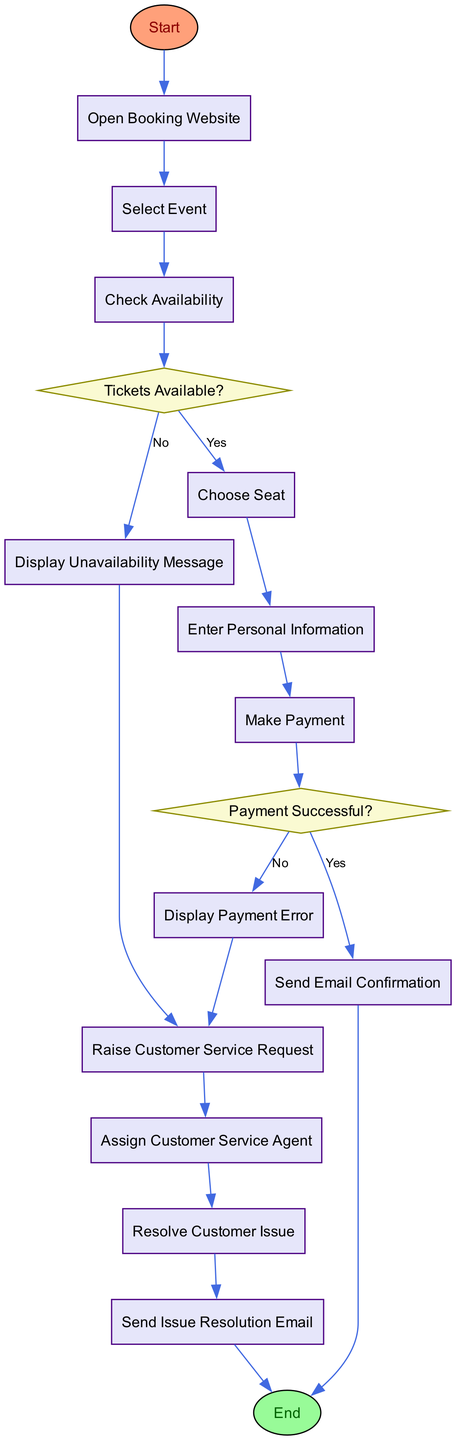What is the first step in the ticket booking process? The flowchart starts with the "Start" node, leading into the "Open Booking Website" process, indicating that this is the first action taken in the ticket booking process.
Answer: Open Booking Website How many decision nodes are present in the flowchart? The flowchart contains two decision nodes: "Tickets Available?" and "Payment Successful?". Therefore, there are two decision points to evaluate during the process.
Answer: 2 What happens if the payment fails? If the payment fails (as indicated by the "Payment Successful?" decision node with a "No" option), the flow proceeds to the "Display Payment Error" process where an error message is shown to the customer.
Answer: Display Payment Error What action follows after the customer selects the event? After the customer selects the event ("Select Event"), the next action in the flowchart is the "Check Availability" process where the system checks if tickets are available for that event.
Answer: Check Availability If tickets are unavailable, what does the system display? In the case where tickets are unavailable (indicated by the "No" path from the "Tickets Available?" decision), the system will display a message indicating that tickets are sold out, as shown in the "Display Unavailability Message" process.
Answer: Display Unavailability Message How does the customer receive confirmation after successful payment? After the payment is confirmed as successful (indicated by the "Yes" path from the "Payment Successful?" decision node), the next process is "Send Email Confirmation," where the system sends an email with ticket details to the customer.
Answer: Send Email Confirmation What steps can the customer take if they encounter an issue after payment? If the customer experiences an issue after payment, they can raise a customer service request via the "Raise Customer Service Request" process, as shown after either "Display Payment Error" or "Display Unavailability Message".
Answer: Raise Customer Service Request What is the final step in the flowchart? The last action indicated in the flowchart is the "End" node, which signifies the conclusion of the ticket booking and customer service handling process.
Answer: End 